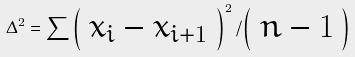<formula> <loc_0><loc_0><loc_500><loc_500>\Delta ^ { 2 } = \sum { \left ( \begin{array} { c } x _ { i } - x _ { i + 1 } \end{array} \right ) ^ { 2 } / \left ( \begin{array} { c } n - 1 \end{array} \right ) }</formula> 